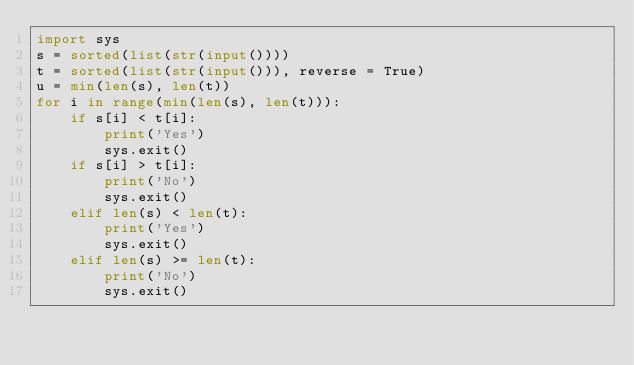<code> <loc_0><loc_0><loc_500><loc_500><_Python_>import sys
s = sorted(list(str(input())))
t = sorted(list(str(input())), reverse = True)
u = min(len(s), len(t))
for i in range(min(len(s), len(t))):
    if s[i] < t[i]:
        print('Yes')
        sys.exit()
    if s[i] > t[i]:
        print('No')
        sys.exit()
    elif len(s) < len(t):
        print('Yes')
        sys.exit()
    elif len(s) >= len(t):
        print('No')
        sys.exit()</code> 